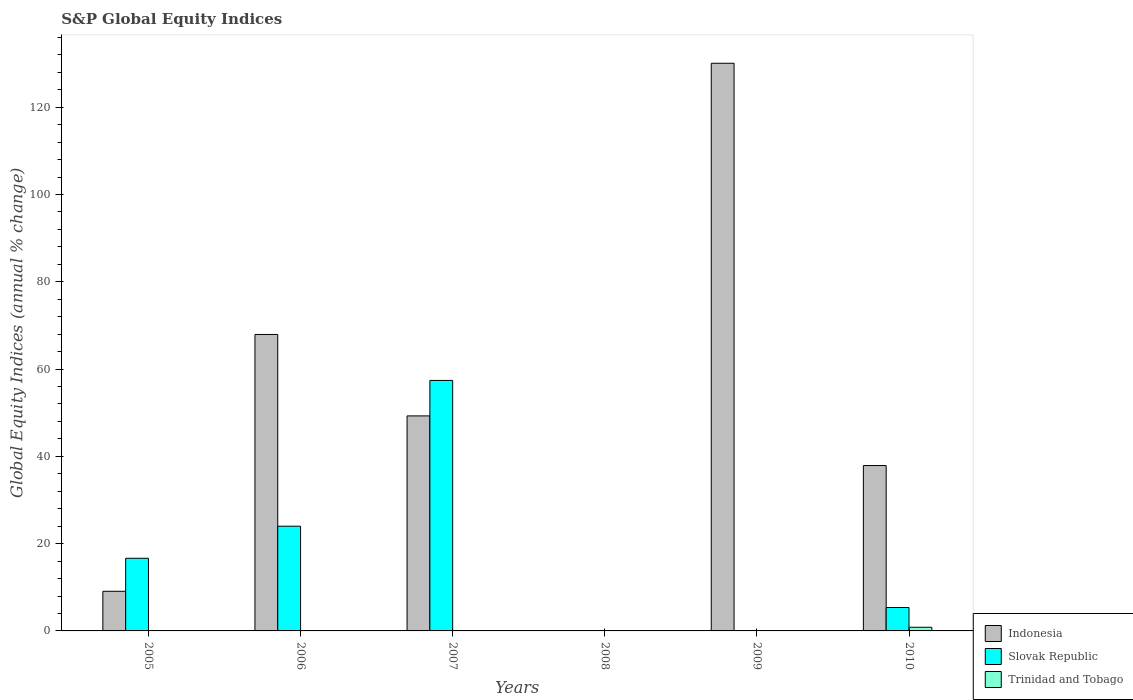How many different coloured bars are there?
Ensure brevity in your answer.  3. Are the number of bars on each tick of the X-axis equal?
Provide a succinct answer. No. How many bars are there on the 2nd tick from the left?
Your answer should be compact. 2. Across all years, what is the maximum global equity indices in Slovak Republic?
Give a very brief answer. 57.39. Across all years, what is the minimum global equity indices in Indonesia?
Ensure brevity in your answer.  0. In which year was the global equity indices in Slovak Republic maximum?
Provide a short and direct response. 2007. What is the total global equity indices in Slovak Republic in the graph?
Ensure brevity in your answer.  103.4. What is the difference between the global equity indices in Indonesia in 2006 and that in 2010?
Your answer should be compact. 30.03. What is the difference between the global equity indices in Trinidad and Tobago in 2009 and the global equity indices in Slovak Republic in 2006?
Your response must be concise. -23.99. What is the average global equity indices in Indonesia per year?
Make the answer very short. 49.04. In the year 2005, what is the difference between the global equity indices in Slovak Republic and global equity indices in Indonesia?
Your response must be concise. 7.57. What is the ratio of the global equity indices in Indonesia in 2005 to that in 2007?
Your answer should be very brief. 0.18. What is the difference between the highest and the second highest global equity indices in Indonesia?
Offer a terse response. 62.14. What is the difference between the highest and the lowest global equity indices in Trinidad and Tobago?
Provide a short and direct response. 0.84. Is the sum of the global equity indices in Indonesia in 2005 and 2007 greater than the maximum global equity indices in Trinidad and Tobago across all years?
Keep it short and to the point. Yes. Is it the case that in every year, the sum of the global equity indices in Slovak Republic and global equity indices in Trinidad and Tobago is greater than the global equity indices in Indonesia?
Offer a very short reply. No. How many bars are there?
Your answer should be very brief. 10. Are all the bars in the graph horizontal?
Provide a short and direct response. No. What is the difference between two consecutive major ticks on the Y-axis?
Offer a terse response. 20. Does the graph contain any zero values?
Your answer should be very brief. Yes. Where does the legend appear in the graph?
Provide a succinct answer. Bottom right. How many legend labels are there?
Provide a succinct answer. 3. What is the title of the graph?
Provide a short and direct response. S&P Global Equity Indices. What is the label or title of the X-axis?
Offer a terse response. Years. What is the label or title of the Y-axis?
Your answer should be very brief. Global Equity Indices (annual % change). What is the Global Equity Indices (annual % change) of Indonesia in 2005?
Ensure brevity in your answer.  9.08. What is the Global Equity Indices (annual % change) of Slovak Republic in 2005?
Keep it short and to the point. 16.65. What is the Global Equity Indices (annual % change) of Indonesia in 2006?
Give a very brief answer. 67.93. What is the Global Equity Indices (annual % change) in Slovak Republic in 2006?
Offer a very short reply. 23.99. What is the Global Equity Indices (annual % change) in Indonesia in 2007?
Your answer should be very brief. 49.27. What is the Global Equity Indices (annual % change) in Slovak Republic in 2007?
Your response must be concise. 57.39. What is the Global Equity Indices (annual % change) of Indonesia in 2008?
Offer a terse response. 0. What is the Global Equity Indices (annual % change) in Slovak Republic in 2008?
Offer a terse response. 0. What is the Global Equity Indices (annual % change) in Trinidad and Tobago in 2008?
Provide a succinct answer. 0. What is the Global Equity Indices (annual % change) of Indonesia in 2009?
Make the answer very short. 130.07. What is the Global Equity Indices (annual % change) in Slovak Republic in 2009?
Offer a terse response. 0. What is the Global Equity Indices (annual % change) of Indonesia in 2010?
Keep it short and to the point. 37.89. What is the Global Equity Indices (annual % change) of Slovak Republic in 2010?
Your answer should be very brief. 5.36. What is the Global Equity Indices (annual % change) in Trinidad and Tobago in 2010?
Give a very brief answer. 0.84. Across all years, what is the maximum Global Equity Indices (annual % change) in Indonesia?
Your response must be concise. 130.07. Across all years, what is the maximum Global Equity Indices (annual % change) of Slovak Republic?
Make the answer very short. 57.39. Across all years, what is the maximum Global Equity Indices (annual % change) of Trinidad and Tobago?
Ensure brevity in your answer.  0.84. Across all years, what is the minimum Global Equity Indices (annual % change) in Indonesia?
Ensure brevity in your answer.  0. Across all years, what is the minimum Global Equity Indices (annual % change) of Slovak Republic?
Offer a very short reply. 0. Across all years, what is the minimum Global Equity Indices (annual % change) in Trinidad and Tobago?
Your answer should be very brief. 0. What is the total Global Equity Indices (annual % change) in Indonesia in the graph?
Provide a short and direct response. 294.23. What is the total Global Equity Indices (annual % change) of Slovak Republic in the graph?
Ensure brevity in your answer.  103.4. What is the total Global Equity Indices (annual % change) of Trinidad and Tobago in the graph?
Ensure brevity in your answer.  0.84. What is the difference between the Global Equity Indices (annual % change) of Indonesia in 2005 and that in 2006?
Provide a short and direct response. -58.85. What is the difference between the Global Equity Indices (annual % change) in Slovak Republic in 2005 and that in 2006?
Your answer should be very brief. -7.35. What is the difference between the Global Equity Indices (annual % change) of Indonesia in 2005 and that in 2007?
Keep it short and to the point. -40.19. What is the difference between the Global Equity Indices (annual % change) of Slovak Republic in 2005 and that in 2007?
Provide a short and direct response. -40.75. What is the difference between the Global Equity Indices (annual % change) in Indonesia in 2005 and that in 2009?
Give a very brief answer. -120.99. What is the difference between the Global Equity Indices (annual % change) of Indonesia in 2005 and that in 2010?
Offer a terse response. -28.81. What is the difference between the Global Equity Indices (annual % change) in Slovak Republic in 2005 and that in 2010?
Your answer should be very brief. 11.28. What is the difference between the Global Equity Indices (annual % change) of Indonesia in 2006 and that in 2007?
Your answer should be compact. 18.66. What is the difference between the Global Equity Indices (annual % change) in Slovak Republic in 2006 and that in 2007?
Your answer should be very brief. -33.4. What is the difference between the Global Equity Indices (annual % change) of Indonesia in 2006 and that in 2009?
Provide a short and direct response. -62.14. What is the difference between the Global Equity Indices (annual % change) in Indonesia in 2006 and that in 2010?
Your answer should be compact. 30.03. What is the difference between the Global Equity Indices (annual % change) in Slovak Republic in 2006 and that in 2010?
Ensure brevity in your answer.  18.63. What is the difference between the Global Equity Indices (annual % change) of Indonesia in 2007 and that in 2009?
Make the answer very short. -80.8. What is the difference between the Global Equity Indices (annual % change) in Indonesia in 2007 and that in 2010?
Ensure brevity in your answer.  11.37. What is the difference between the Global Equity Indices (annual % change) of Slovak Republic in 2007 and that in 2010?
Make the answer very short. 52.03. What is the difference between the Global Equity Indices (annual % change) of Indonesia in 2009 and that in 2010?
Provide a short and direct response. 92.17. What is the difference between the Global Equity Indices (annual % change) in Indonesia in 2005 and the Global Equity Indices (annual % change) in Slovak Republic in 2006?
Your answer should be compact. -14.91. What is the difference between the Global Equity Indices (annual % change) of Indonesia in 2005 and the Global Equity Indices (annual % change) of Slovak Republic in 2007?
Your answer should be compact. -48.32. What is the difference between the Global Equity Indices (annual % change) in Indonesia in 2005 and the Global Equity Indices (annual % change) in Slovak Republic in 2010?
Your response must be concise. 3.71. What is the difference between the Global Equity Indices (annual % change) in Indonesia in 2005 and the Global Equity Indices (annual % change) in Trinidad and Tobago in 2010?
Keep it short and to the point. 8.24. What is the difference between the Global Equity Indices (annual % change) of Slovak Republic in 2005 and the Global Equity Indices (annual % change) of Trinidad and Tobago in 2010?
Keep it short and to the point. 15.81. What is the difference between the Global Equity Indices (annual % change) of Indonesia in 2006 and the Global Equity Indices (annual % change) of Slovak Republic in 2007?
Provide a short and direct response. 10.53. What is the difference between the Global Equity Indices (annual % change) of Indonesia in 2006 and the Global Equity Indices (annual % change) of Slovak Republic in 2010?
Your answer should be compact. 62.56. What is the difference between the Global Equity Indices (annual % change) of Indonesia in 2006 and the Global Equity Indices (annual % change) of Trinidad and Tobago in 2010?
Ensure brevity in your answer.  67.09. What is the difference between the Global Equity Indices (annual % change) of Slovak Republic in 2006 and the Global Equity Indices (annual % change) of Trinidad and Tobago in 2010?
Offer a very short reply. 23.15. What is the difference between the Global Equity Indices (annual % change) of Indonesia in 2007 and the Global Equity Indices (annual % change) of Slovak Republic in 2010?
Ensure brevity in your answer.  43.9. What is the difference between the Global Equity Indices (annual % change) in Indonesia in 2007 and the Global Equity Indices (annual % change) in Trinidad and Tobago in 2010?
Your answer should be very brief. 48.43. What is the difference between the Global Equity Indices (annual % change) of Slovak Republic in 2007 and the Global Equity Indices (annual % change) of Trinidad and Tobago in 2010?
Keep it short and to the point. 56.56. What is the difference between the Global Equity Indices (annual % change) of Indonesia in 2009 and the Global Equity Indices (annual % change) of Slovak Republic in 2010?
Your answer should be very brief. 124.7. What is the difference between the Global Equity Indices (annual % change) of Indonesia in 2009 and the Global Equity Indices (annual % change) of Trinidad and Tobago in 2010?
Your answer should be compact. 129.23. What is the average Global Equity Indices (annual % change) of Indonesia per year?
Give a very brief answer. 49.04. What is the average Global Equity Indices (annual % change) in Slovak Republic per year?
Provide a short and direct response. 17.23. What is the average Global Equity Indices (annual % change) in Trinidad and Tobago per year?
Your answer should be very brief. 0.14. In the year 2005, what is the difference between the Global Equity Indices (annual % change) in Indonesia and Global Equity Indices (annual % change) in Slovak Republic?
Your response must be concise. -7.57. In the year 2006, what is the difference between the Global Equity Indices (annual % change) in Indonesia and Global Equity Indices (annual % change) in Slovak Republic?
Provide a succinct answer. 43.94. In the year 2007, what is the difference between the Global Equity Indices (annual % change) in Indonesia and Global Equity Indices (annual % change) in Slovak Republic?
Your answer should be compact. -8.13. In the year 2010, what is the difference between the Global Equity Indices (annual % change) of Indonesia and Global Equity Indices (annual % change) of Slovak Republic?
Provide a succinct answer. 32.53. In the year 2010, what is the difference between the Global Equity Indices (annual % change) in Indonesia and Global Equity Indices (annual % change) in Trinidad and Tobago?
Provide a short and direct response. 37.05. In the year 2010, what is the difference between the Global Equity Indices (annual % change) of Slovak Republic and Global Equity Indices (annual % change) of Trinidad and Tobago?
Your response must be concise. 4.53. What is the ratio of the Global Equity Indices (annual % change) in Indonesia in 2005 to that in 2006?
Your response must be concise. 0.13. What is the ratio of the Global Equity Indices (annual % change) of Slovak Republic in 2005 to that in 2006?
Provide a short and direct response. 0.69. What is the ratio of the Global Equity Indices (annual % change) of Indonesia in 2005 to that in 2007?
Offer a terse response. 0.18. What is the ratio of the Global Equity Indices (annual % change) of Slovak Republic in 2005 to that in 2007?
Provide a succinct answer. 0.29. What is the ratio of the Global Equity Indices (annual % change) in Indonesia in 2005 to that in 2009?
Your answer should be very brief. 0.07. What is the ratio of the Global Equity Indices (annual % change) in Indonesia in 2005 to that in 2010?
Keep it short and to the point. 0.24. What is the ratio of the Global Equity Indices (annual % change) of Slovak Republic in 2005 to that in 2010?
Ensure brevity in your answer.  3.1. What is the ratio of the Global Equity Indices (annual % change) in Indonesia in 2006 to that in 2007?
Offer a very short reply. 1.38. What is the ratio of the Global Equity Indices (annual % change) in Slovak Republic in 2006 to that in 2007?
Offer a very short reply. 0.42. What is the ratio of the Global Equity Indices (annual % change) of Indonesia in 2006 to that in 2009?
Give a very brief answer. 0.52. What is the ratio of the Global Equity Indices (annual % change) of Indonesia in 2006 to that in 2010?
Offer a terse response. 1.79. What is the ratio of the Global Equity Indices (annual % change) in Slovak Republic in 2006 to that in 2010?
Make the answer very short. 4.47. What is the ratio of the Global Equity Indices (annual % change) of Indonesia in 2007 to that in 2009?
Give a very brief answer. 0.38. What is the ratio of the Global Equity Indices (annual % change) of Indonesia in 2007 to that in 2010?
Give a very brief answer. 1.3. What is the ratio of the Global Equity Indices (annual % change) of Slovak Republic in 2007 to that in 2010?
Ensure brevity in your answer.  10.7. What is the ratio of the Global Equity Indices (annual % change) in Indonesia in 2009 to that in 2010?
Your answer should be compact. 3.43. What is the difference between the highest and the second highest Global Equity Indices (annual % change) of Indonesia?
Give a very brief answer. 62.14. What is the difference between the highest and the second highest Global Equity Indices (annual % change) in Slovak Republic?
Your response must be concise. 33.4. What is the difference between the highest and the lowest Global Equity Indices (annual % change) in Indonesia?
Offer a terse response. 130.07. What is the difference between the highest and the lowest Global Equity Indices (annual % change) in Slovak Republic?
Ensure brevity in your answer.  57.39. What is the difference between the highest and the lowest Global Equity Indices (annual % change) of Trinidad and Tobago?
Your answer should be compact. 0.84. 